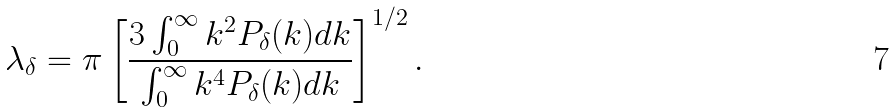Convert formula to latex. <formula><loc_0><loc_0><loc_500><loc_500>\lambda _ { \delta } = \pi \left [ \frac { 3 \int ^ { \infty } _ { 0 } k ^ { 2 } P _ { \delta } ( k ) d k } { \int ^ { \infty } _ { 0 } k ^ { 4 } P _ { \delta } ( k ) d k } \right ] ^ { 1 / 2 } .</formula> 